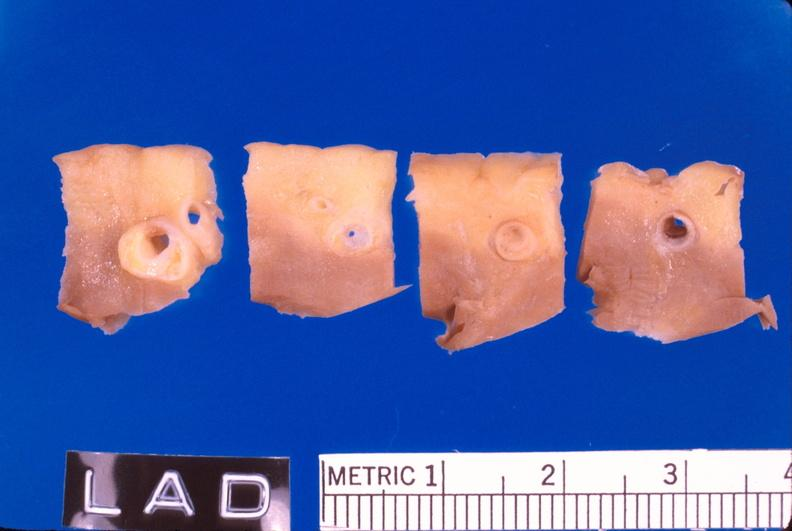does this image show coronary artery atherosclerosis?
Answer the question using a single word or phrase. Yes 